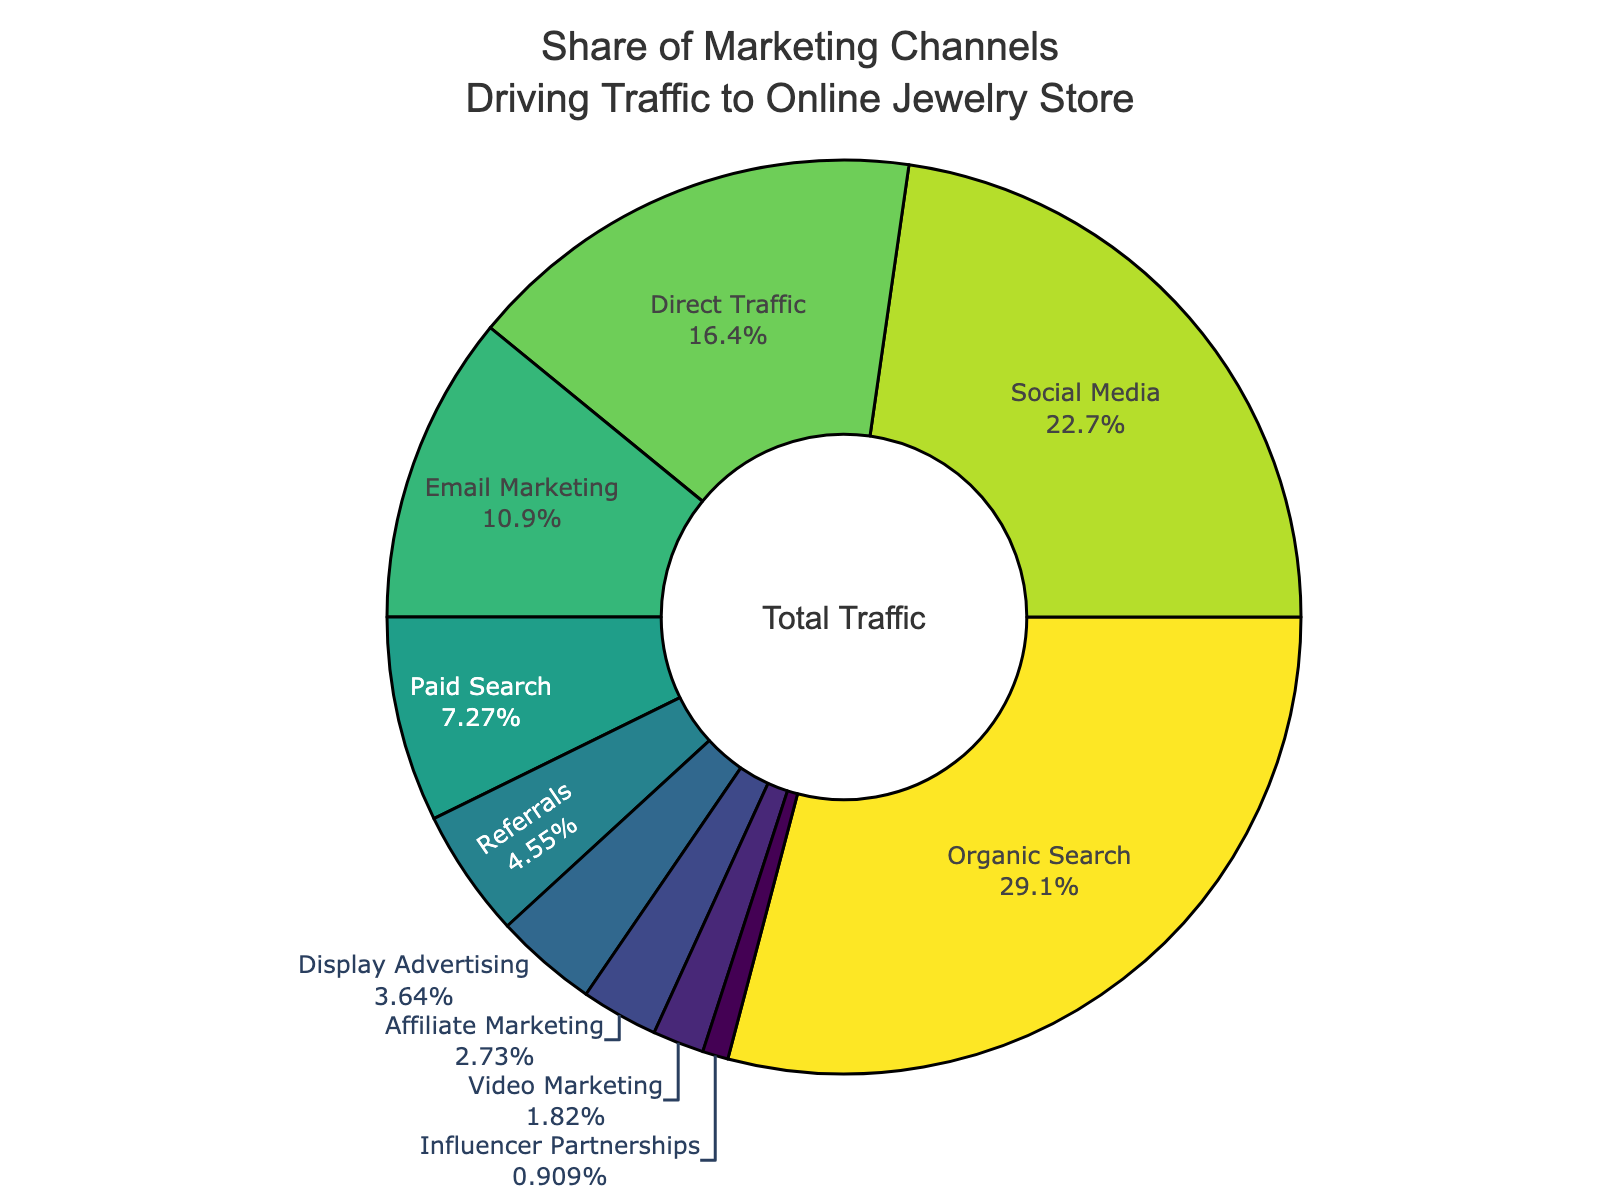How much traffic does Social Media and Email Marketing contribute to together? Social Media contributes 25% and Email Marketing contributes 12%. Adding these together gives 25% + 12% = 37%.
Answer: 37% What is the difference between the traffic driven by Organic Search and Paid Search? Organic Search contributes 32% and Paid Search contributes 8%. The difference is 32% - 8% = 24%.
Answer: 24% Which marketing channel drives the least traffic to the online jewelry store? The channel driving the least traffic is Influencer Partnerships at 1%.
Answer: Influencer Partnerships Does Direct Traffic contribute more or less than Display Advertising and Affiliate Marketing combined? Direct Traffic contributes 18%. Display Advertising and Affiliate Marketing contribute 4% + 3% = 7% combined. 18% is greater than 7%.
Answer: More What percentage of traffic is driven by channels other than Organic Search and Social Media? The traffic driven by Organic Search is 32% and by Social Media is 25%. Adding them together gives 32% + 25% = 57%. The remaining traffic is 100% - 57% = 43%.
Answer: 43% Which color represents the traffic from Paid Search in the pie chart? Each slice of the pie chart is marked with specific colors. By matching the label 'Paid Search' with its corresponding color slice, we can see the color.
Answer: Bright green (from the Viridis palette) What is the combined percentage of traffic driven by Email Marketing, Referrals, and Display Advertising? Email Marketing contributes 12%, Referrals contributes 5%, and Display Advertising contributes 4%. Adding these together gives 12% + 5% + 4% = 21%.
Answer: 21% Are there more traffic sources contributing below 5% or above 5%? Traffic sources below 5% are Referrals, Display Advertising, Affiliate Marketing, Video Marketing, and Influencer Partnerships (totaling 5 sources). Traffic sources above 5% are Organic Search, Social Media, Direct Traffic, Email Marketing, and Paid Search (totaling 5 sources). Therefore, the number is equal.
Answer: Equal 